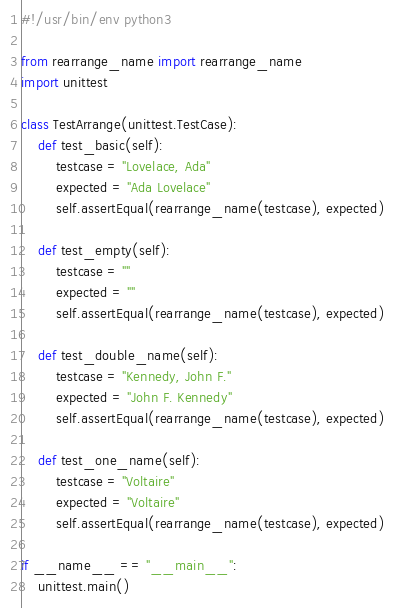Convert code to text. <code><loc_0><loc_0><loc_500><loc_500><_Python_>#!/usr/bin/env python3

from rearrange_name import rearrange_name
import unittest

class TestArrange(unittest.TestCase):
	def test_basic(self):
		testcase = "Lovelace, Ada"
		expected = "Ada Lovelace"
		self.assertEqual(rearrange_name(testcase), expected)

	def test_empty(self):
		testcase = ""
		expected = ""
		self.assertEqual(rearrange_name(testcase), expected)

	def test_double_name(self):
		testcase = "Kennedy, John F."
		expected = "John F. Kennedy"
		self.assertEqual(rearrange_name(testcase), expected)

	def test_one_name(self):
		testcase = "Voltaire"
		expected = "Voltaire"
		self.assertEqual(rearrange_name(testcase), expected)

if __name__ == "__main__":
	unittest.main()</code> 